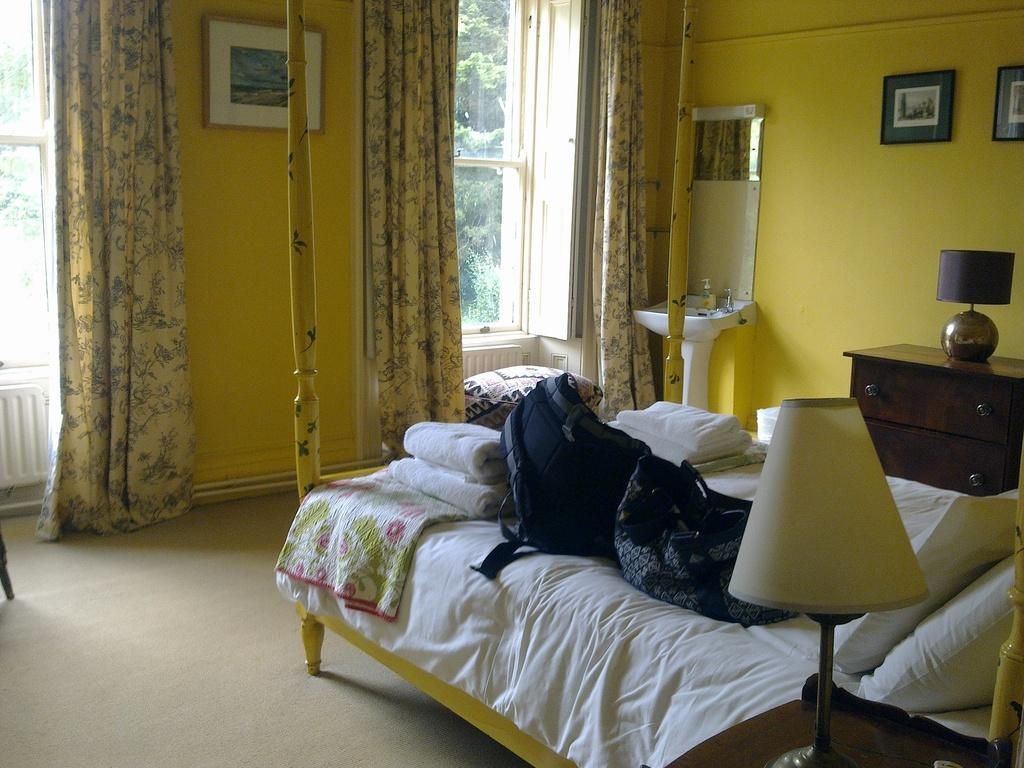Can you describe this image briefly? There is a bed in this picture on which some bags were placed. There is a lamp on the table. In the background there is a curtain, wall, some photographs attached to the wall. Through the window we can observe some trees here. 